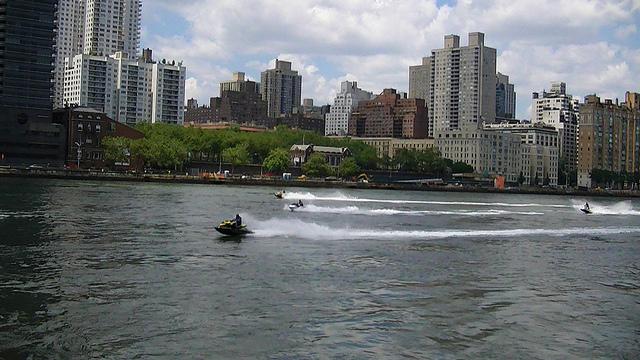Where are they going?
Be succinct. Up river. Is this a small town or a city?
Write a very short answer. City. Are these boats?
Keep it brief. No. 